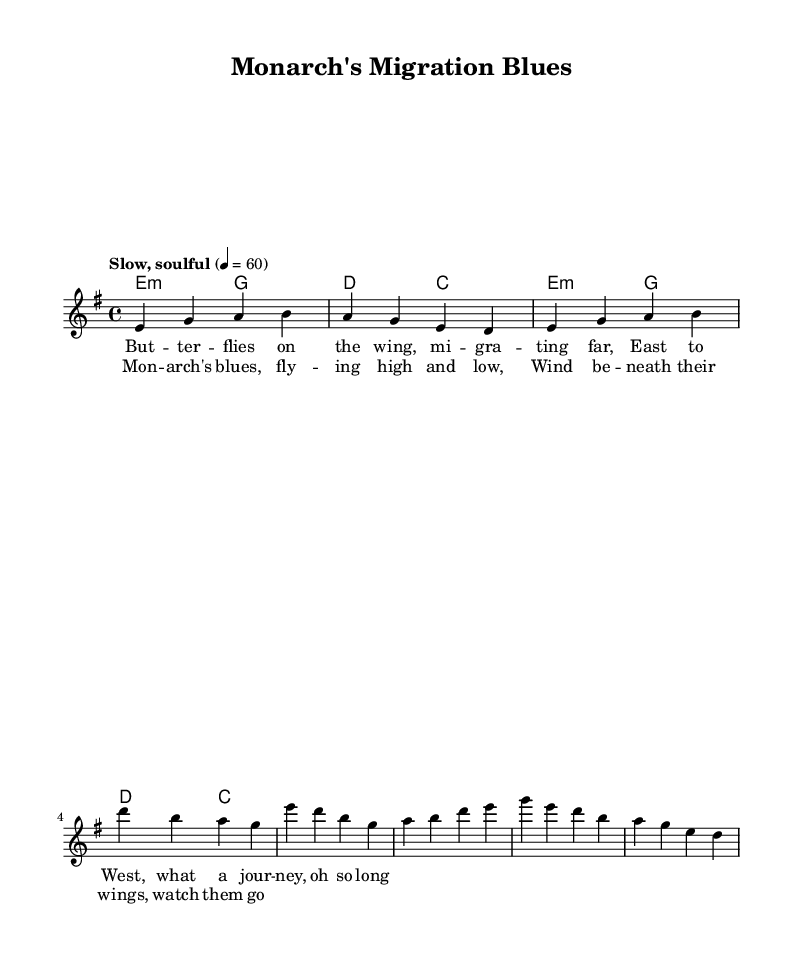What is the key signature of this music? The key signature is E minor, which has one sharp (F#).
Answer: E minor What is the time signature of the piece? The time signature is 4/4, indicating four beats per measure.
Answer: 4/4 What is the tempo marking for this piece? The tempo marking is "Slow, soulful," suggesting a relaxed musical pace.
Answer: Slow, soulful How many measures are in the verse? The verse contains 4 measures, as indicated by the grouping of notes.
Answer: 4 What is the primary chord used in the melody during the verse? The primary chord in the melody during the verse is E minor, as seen in the chord changes.
Answer: E minor What do the lyrics of the chorus depict? The lyrics of the chorus depict the journey of the Monarch butterfly, reflecting themes of freedom and migration.
Answer: Monarch's blues How do the lyrical themes relate to the Delta blues style? The lyrical themes connect to Delta blues by expressing emotional storytelling and the struggle of migration, a common theme in blues music.
Answer: Emotional storytelling 